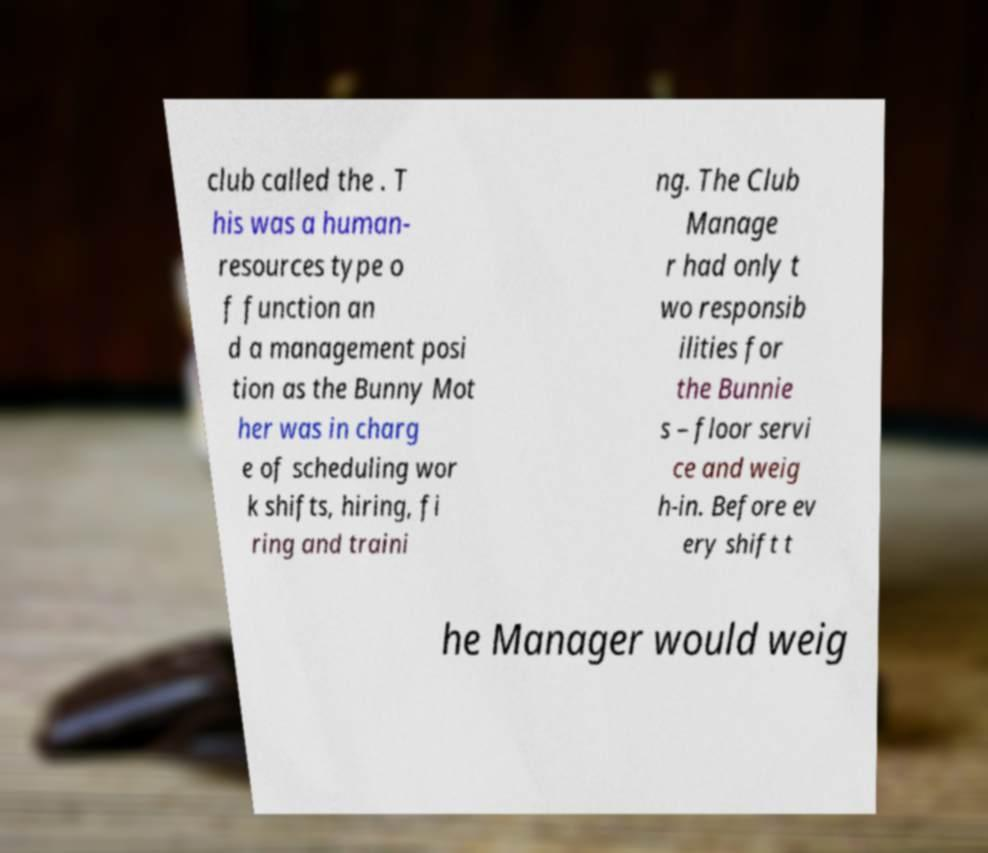Can you accurately transcribe the text from the provided image for me? club called the . T his was a human- resources type o f function an d a management posi tion as the Bunny Mot her was in charg e of scheduling wor k shifts, hiring, fi ring and traini ng. The Club Manage r had only t wo responsib ilities for the Bunnie s – floor servi ce and weig h-in. Before ev ery shift t he Manager would weig 